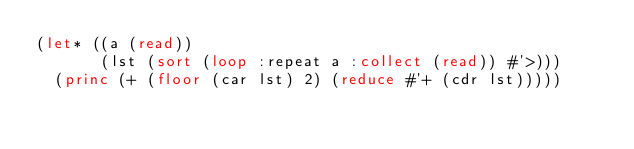Convert code to text. <code><loc_0><loc_0><loc_500><loc_500><_Lisp_>(let* ((a (read))
       (lst (sort (loop :repeat a :collect (read)) #'>)))
  (princ (+ (floor (car lst) 2) (reduce #'+ (cdr lst)))))</code> 